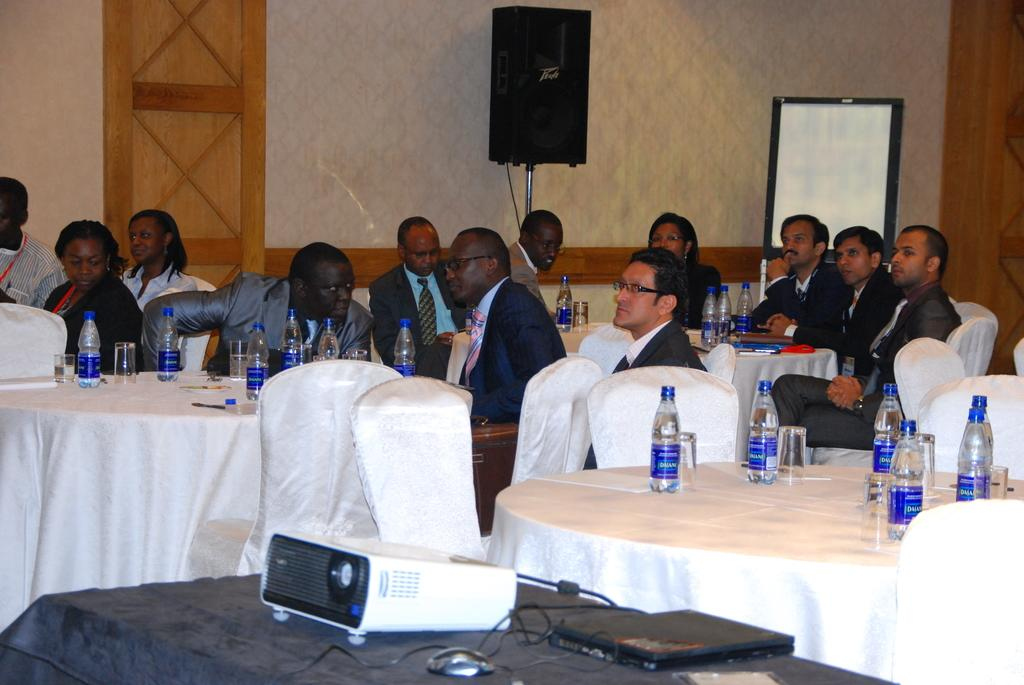How many people are in the image? There is a group of people in the image, but the exact number cannot be determined from the provided facts. What are the people doing in the image? The people are sitting on chairs in the image. What is on the tables in front of the chairs? Bottles of water are present on the tables. What can be seen on a table at the bottom of the image? There is a projector on a table at the bottom of the image. Where is the pail located in the image? There is no pail present in the image. What color is the brain of the person sitting on the chair? There is no brain visible in the image, as it is a photograph of people sitting on chairs. 